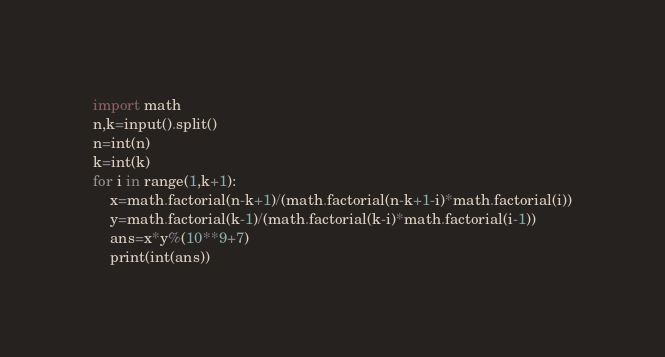Convert code to text. <code><loc_0><loc_0><loc_500><loc_500><_Python_>import math
n,k=input().split()
n=int(n)
k=int(k)
for i in range(1,k+1):
    x=math.factorial(n-k+1)/(math.factorial(n-k+1-i)*math.factorial(i))
    y=math.factorial(k-1)/(math.factorial(k-i)*math.factorial(i-1))
    ans=x*y%(10**9+7)
    print(int(ans))</code> 